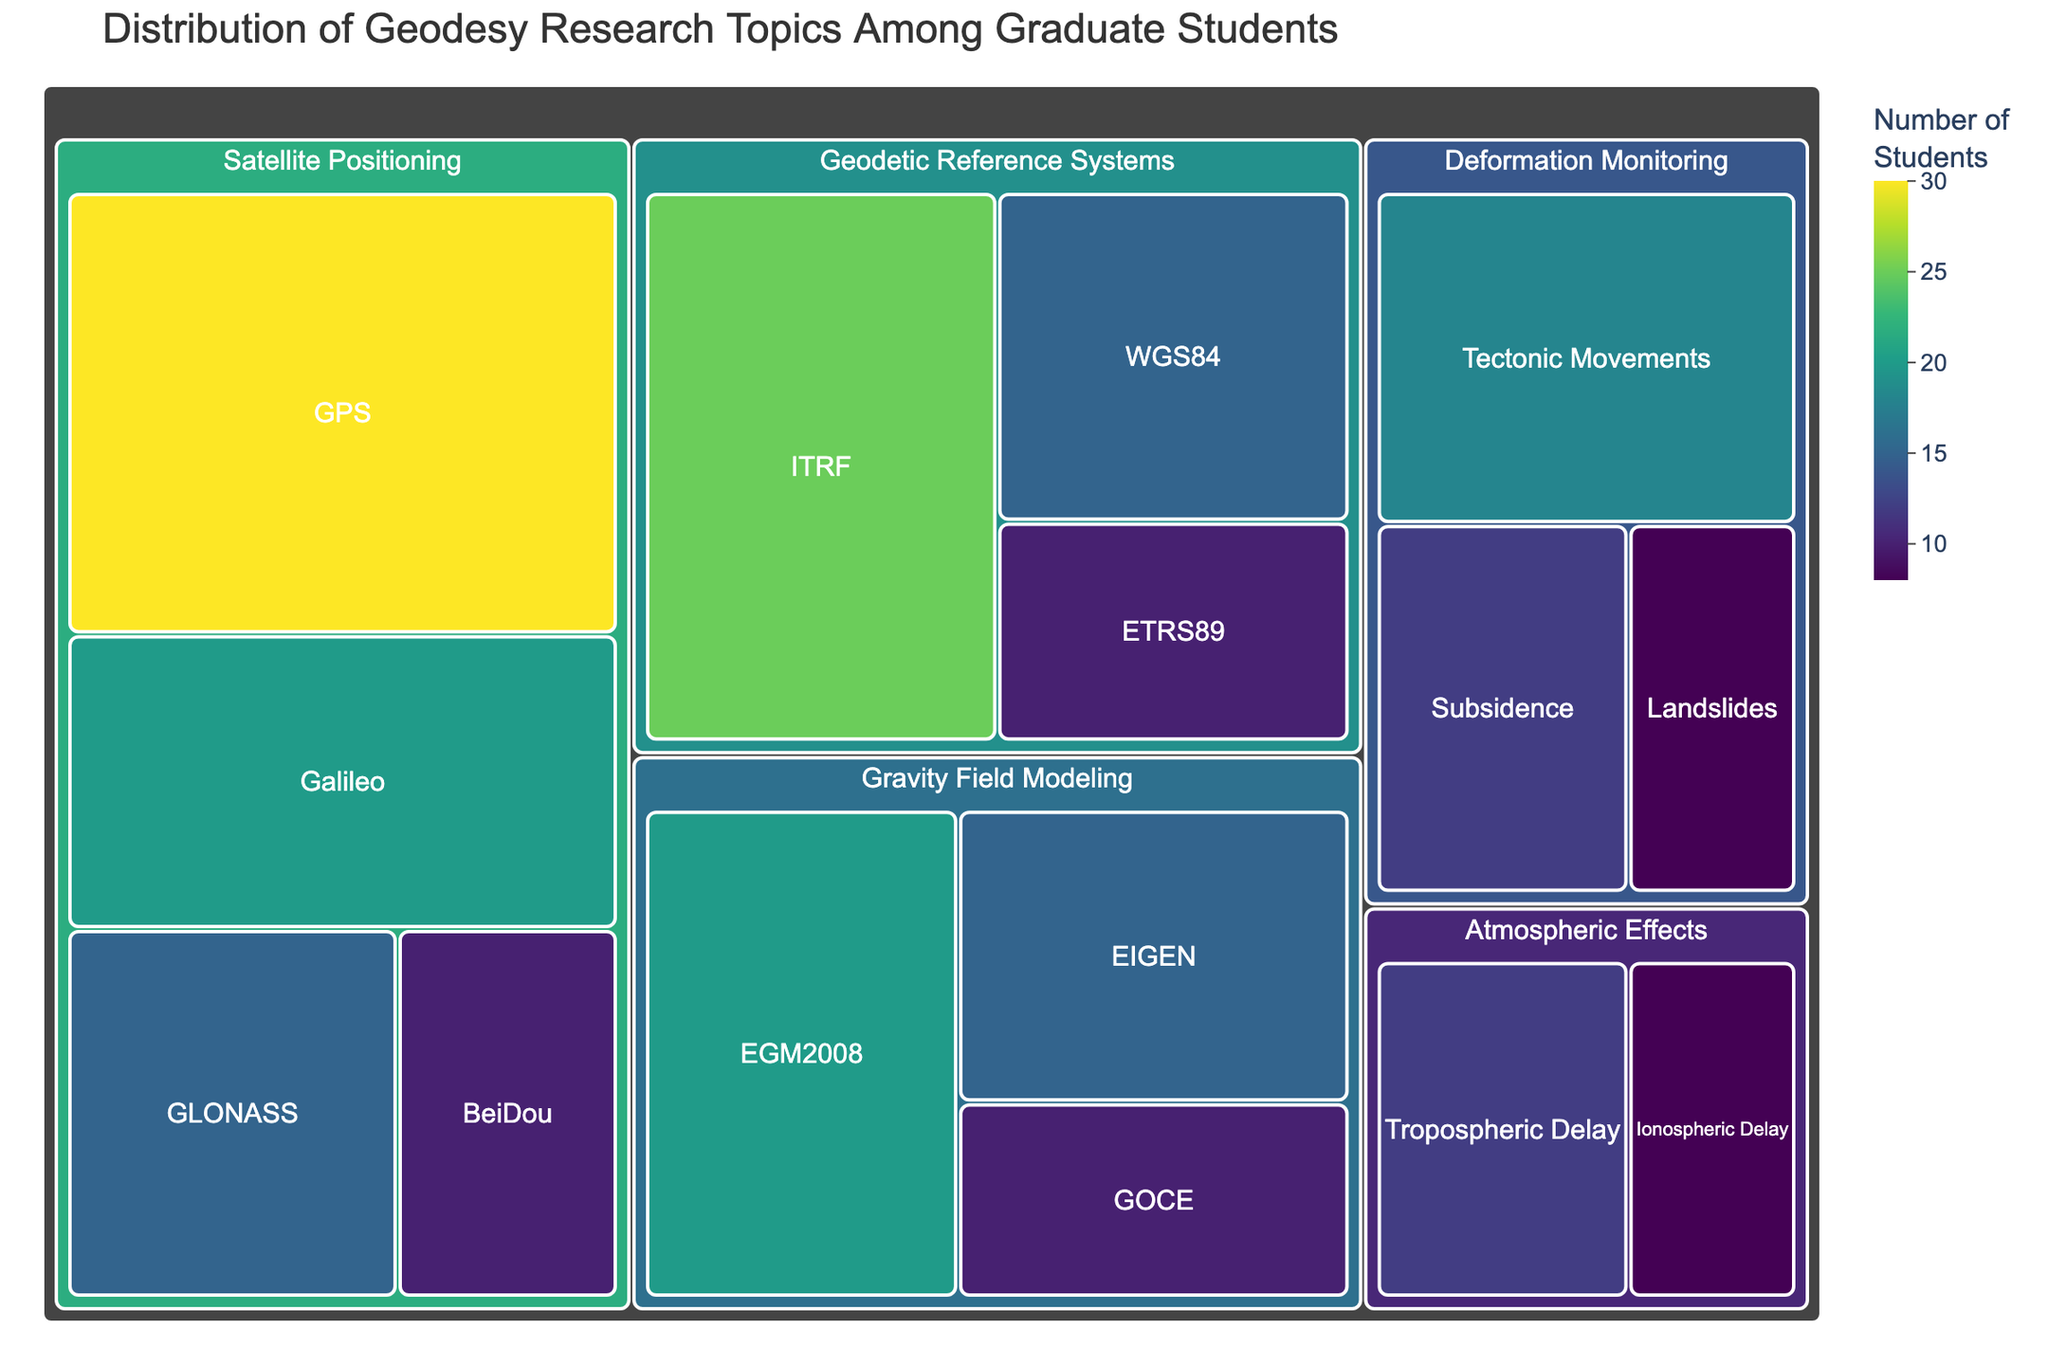what is the title of the treemap figure? The title is located at the top of the figure and summarizes the overall theme. It reads "Distribution of Geodesy Research Topics Among Graduate Students".
Answer: Distribution of Geodesy Research Topics Among Graduate Students which research topic has the most graduate students? Look at the size of the tiles; the largest tile within the "Satellite Positioning" category is for "GPS" with a value of 30, which is the highest number among all subcategories.
Answer: GPS how many students are studying "Deformation Monitoring"? Deformation Monitoring consists of three subcategories: Tectonic Movements (18), Subsidence (12), and Landslides (8). Sum these up to get the total number of students. 18 + 12 + 8 = 38
Answer: 38 which category has a smaller number of students: "Atmospheric Effects" or "Gravity Field Modeling"? Compare the sum of the subcategories: Atmospheric Effects (Tropospheric Delay: 12, Ionospheric Delay: 8) gives a total of 20; Gravity Field Modeling (EGM2008: 20, EIGEN: 15, GOCE: 10) gives a total of 45.
Answer: Atmospheric Effects how many subcategories are there in total in the treemap? Count all the subcategories listed under each category: Satellite Positioning (4), Geodetic Reference Systems (3), Gravity Field Modeling (3), Atmospheric Effects (2), Deformation Monitoring (3). Sum these: 4 + 3 + 3 + 2 + 3 = 15
Answer: 15 which subcategory in "Geodetic Reference Systems" has the fewest students? Within the Geodetic Reference Systems category, compare the student numbers: ITRF (25), WGS84 (15), ETRS89 (10). The smallest is ETRS89 with 10 students.
Answer: ETRS89 what is the difference in the number of students between the largest and smallest subcategories in "Satellite Positioning"? In Satellite Positioning, GPS has 30 students (largest) and BeiDou has 10 students (smallest). The difference is 30 - 10 = 20
Answer: 20 which specialization is more popular: "GLONASS" or "Tectonic Movements"? Compare the values for both subcategories. GLONASS has 15 students and Tectonic Movements has 18 students. Tectonic Movements is more popular.
Answer: Tectonic Movements what is the average number of students per subcategory in the "Gravity Field Modeling" category? Add the number of students in EGM2008 (20), EIGEN (15), and GOCE (10), and divide by the number of subcategories (3). (20 + 15 + 10) / 3 = 45 / 3 = 15
Answer: 15 what is the combined number of students studying "EGM2008" and "Galileo"? Sum the values for EGM2008 (20) and Galileo (20). 20 + 20 = 40
Answer: 40 